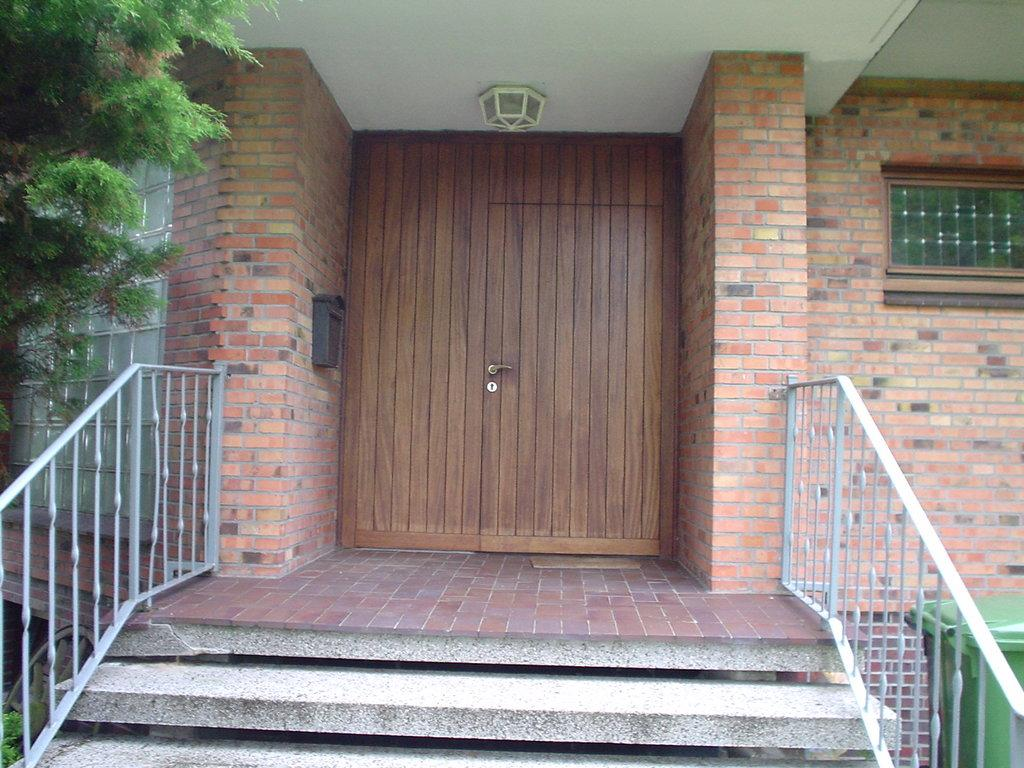What type of door is visible in the image? There is a wooden door in the image. What other structures can be seen in the image? There are walls in the image. What is the purpose of the object located near the door? There is a dustbin in the image. What architectural feature is present in the image? There are steps in the image. What type of vegetation is visible in the image? There are trees in the image. What type of gold object is visible in the image? There is no gold object present in the image. What type of truck can be seen driving through the trees in the image? There is no truck present in the image; it only features a wooden door, walls, a dustbin, steps, and trees. 